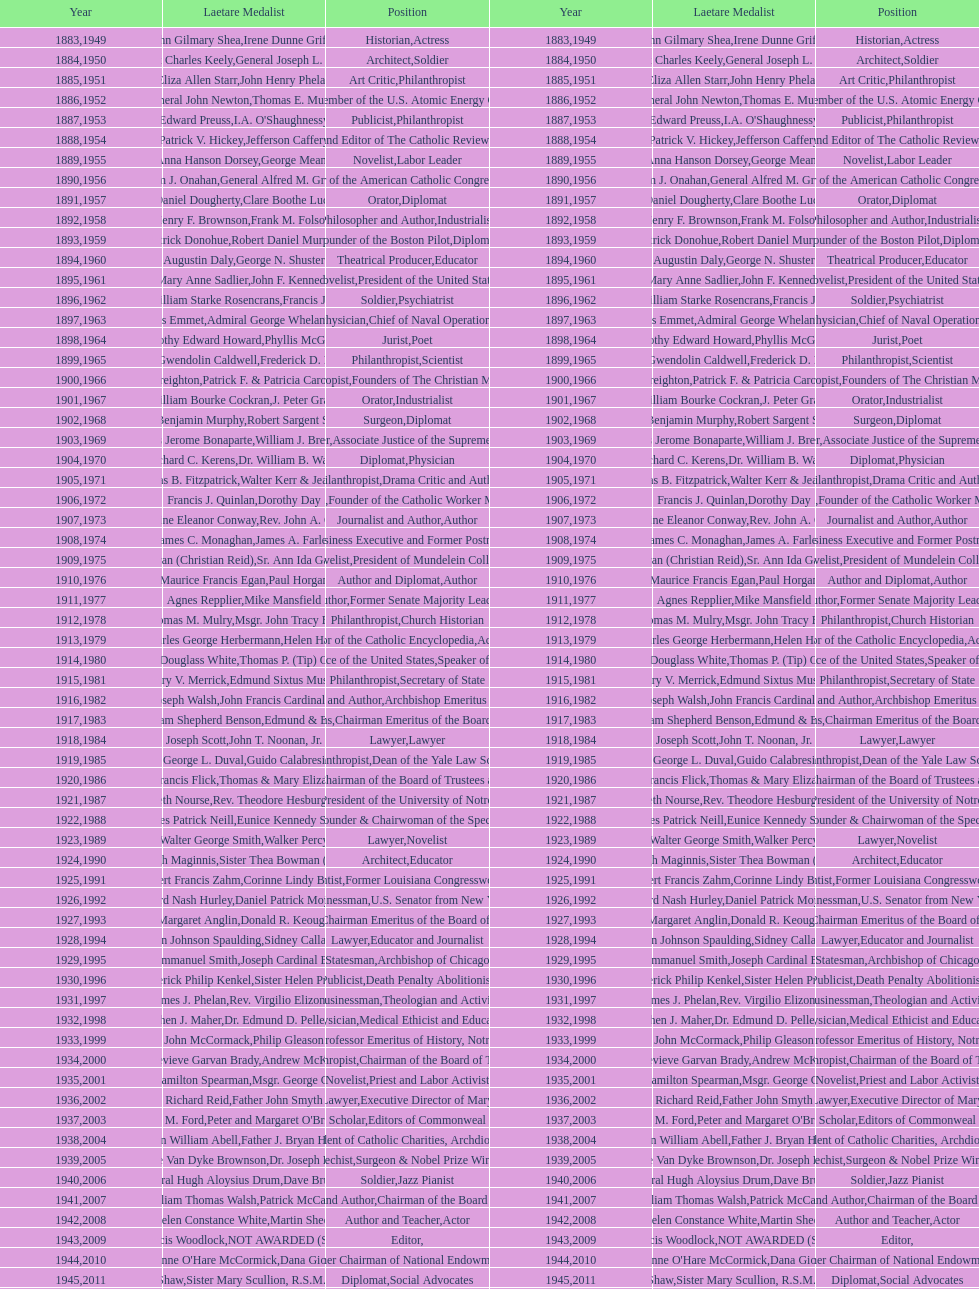Who was the previous winner before john henry phelan in 1951? General Joseph L. Collins. 